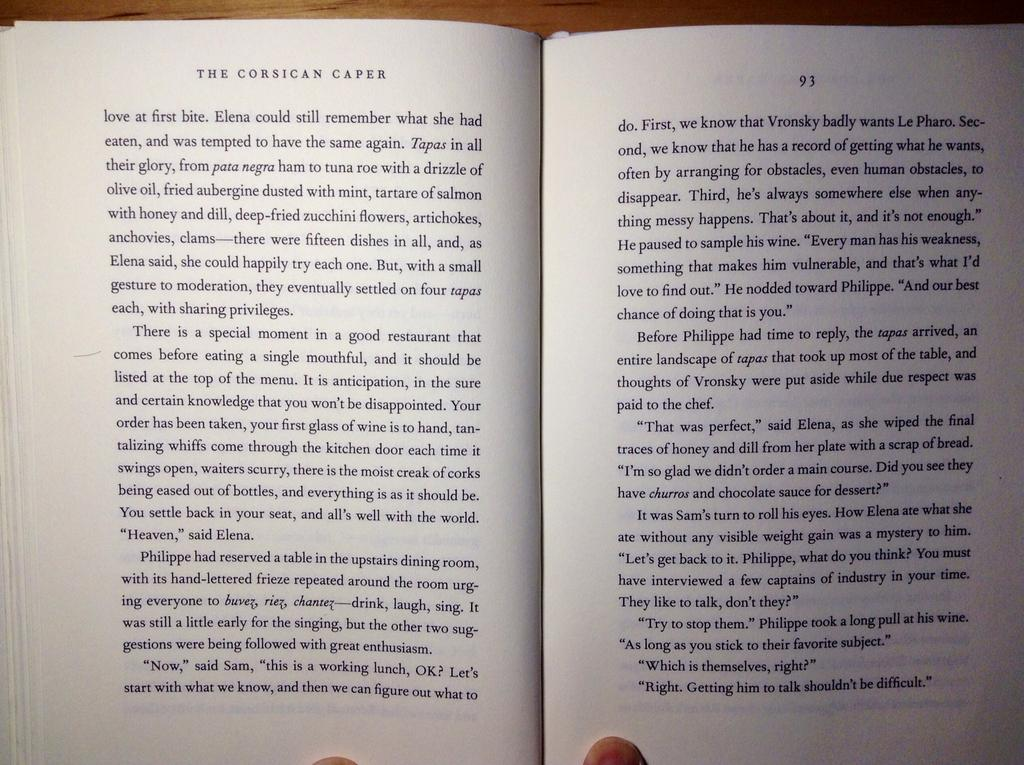<image>
Relay a brief, clear account of the picture shown. A book open to a page titled The Corsican Caper. 